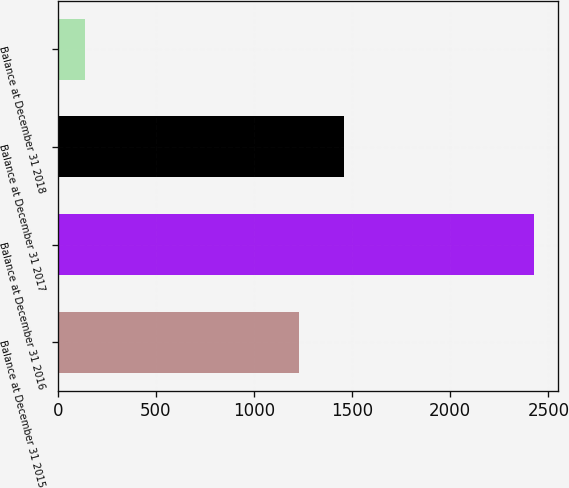Convert chart to OTSL. <chart><loc_0><loc_0><loc_500><loc_500><bar_chart><fcel>Balance at December 31 2015<fcel>Balance at December 31 2016<fcel>Balance at December 31 2017<fcel>Balance at December 31 2018<nl><fcel>1230<fcel>2429<fcel>1459.3<fcel>136<nl></chart> 